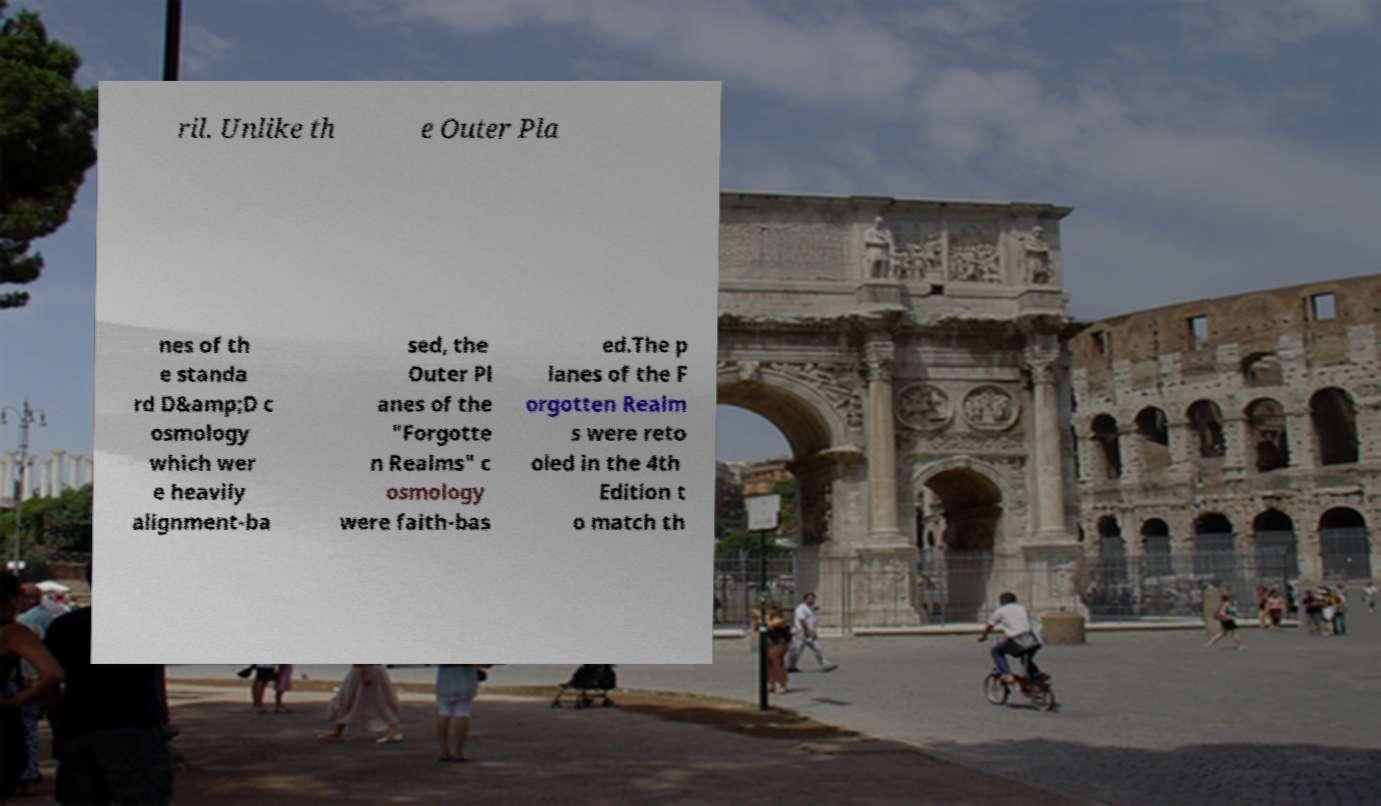Could you assist in decoding the text presented in this image and type it out clearly? ril. Unlike th e Outer Pla nes of th e standa rd D&amp;D c osmology which wer e heavily alignment-ba sed, the Outer Pl anes of the "Forgotte n Realms" c osmology were faith-bas ed.The p lanes of the F orgotten Realm s were reto oled in the 4th Edition t o match th 